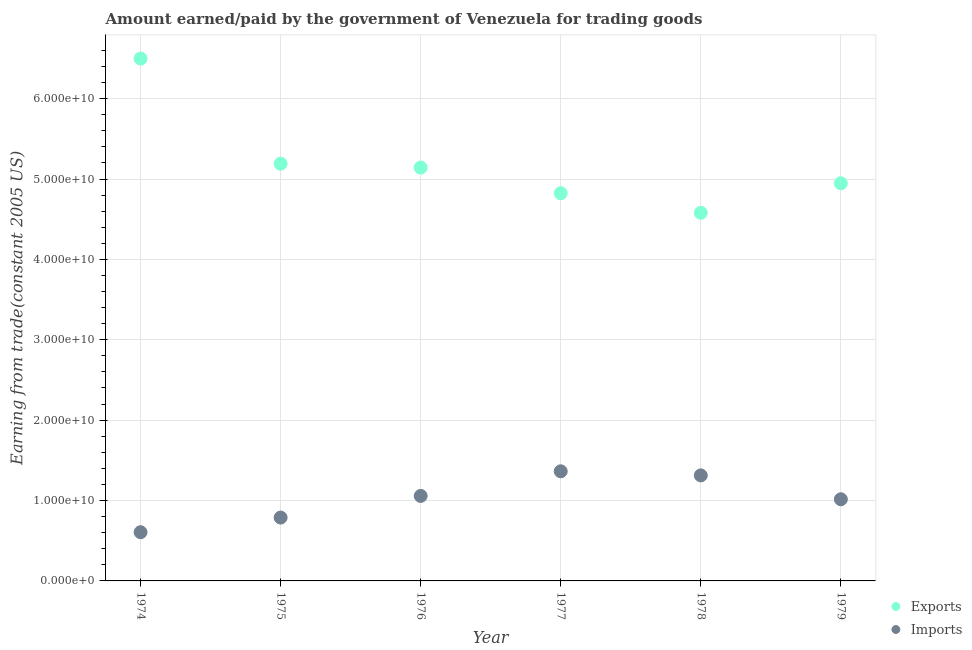What is the amount paid for imports in 1974?
Your answer should be compact. 6.06e+09. Across all years, what is the maximum amount paid for imports?
Give a very brief answer. 1.36e+1. Across all years, what is the minimum amount paid for imports?
Provide a short and direct response. 6.06e+09. In which year was the amount earned from exports maximum?
Your answer should be compact. 1974. In which year was the amount paid for imports minimum?
Your answer should be compact. 1974. What is the total amount paid for imports in the graph?
Ensure brevity in your answer.  6.14e+1. What is the difference between the amount earned from exports in 1975 and that in 1979?
Ensure brevity in your answer.  2.44e+09. What is the difference between the amount earned from exports in 1975 and the amount paid for imports in 1977?
Your answer should be compact. 3.83e+1. What is the average amount earned from exports per year?
Your answer should be very brief. 5.20e+1. In the year 1978, what is the difference between the amount paid for imports and amount earned from exports?
Ensure brevity in your answer.  -3.27e+1. What is the ratio of the amount paid for imports in 1975 to that in 1978?
Give a very brief answer. 0.6. Is the difference between the amount paid for imports in 1975 and 1978 greater than the difference between the amount earned from exports in 1975 and 1978?
Give a very brief answer. No. What is the difference between the highest and the second highest amount paid for imports?
Give a very brief answer. 5.11e+08. What is the difference between the highest and the lowest amount earned from exports?
Ensure brevity in your answer.  1.92e+1. In how many years, is the amount paid for imports greater than the average amount paid for imports taken over all years?
Give a very brief answer. 3. Is the sum of the amount paid for imports in 1978 and 1979 greater than the maximum amount earned from exports across all years?
Make the answer very short. No. Is the amount earned from exports strictly greater than the amount paid for imports over the years?
Offer a very short reply. Yes. Is the amount paid for imports strictly less than the amount earned from exports over the years?
Offer a terse response. Yes. How many dotlines are there?
Provide a short and direct response. 2. Does the graph contain any zero values?
Your answer should be very brief. No. Where does the legend appear in the graph?
Provide a succinct answer. Bottom right. How many legend labels are there?
Keep it short and to the point. 2. What is the title of the graph?
Your answer should be compact. Amount earned/paid by the government of Venezuela for trading goods. Does "Commercial bank branches" appear as one of the legend labels in the graph?
Provide a succinct answer. No. What is the label or title of the Y-axis?
Provide a succinct answer. Earning from trade(constant 2005 US). What is the Earning from trade(constant 2005 US) in Exports in 1974?
Provide a short and direct response. 6.50e+1. What is the Earning from trade(constant 2005 US) in Imports in 1974?
Offer a terse response. 6.06e+09. What is the Earning from trade(constant 2005 US) in Exports in 1975?
Your answer should be compact. 5.19e+1. What is the Earning from trade(constant 2005 US) of Imports in 1975?
Make the answer very short. 7.88e+09. What is the Earning from trade(constant 2005 US) of Exports in 1976?
Make the answer very short. 5.14e+1. What is the Earning from trade(constant 2005 US) in Imports in 1976?
Your response must be concise. 1.06e+1. What is the Earning from trade(constant 2005 US) of Exports in 1977?
Provide a succinct answer. 4.82e+1. What is the Earning from trade(constant 2005 US) of Imports in 1977?
Give a very brief answer. 1.36e+1. What is the Earning from trade(constant 2005 US) of Exports in 1978?
Your answer should be very brief. 4.58e+1. What is the Earning from trade(constant 2005 US) in Imports in 1978?
Make the answer very short. 1.31e+1. What is the Earning from trade(constant 2005 US) in Exports in 1979?
Your answer should be very brief. 4.95e+1. What is the Earning from trade(constant 2005 US) of Imports in 1979?
Your answer should be very brief. 1.02e+1. Across all years, what is the maximum Earning from trade(constant 2005 US) in Exports?
Your response must be concise. 6.50e+1. Across all years, what is the maximum Earning from trade(constant 2005 US) of Imports?
Provide a succinct answer. 1.36e+1. Across all years, what is the minimum Earning from trade(constant 2005 US) in Exports?
Give a very brief answer. 4.58e+1. Across all years, what is the minimum Earning from trade(constant 2005 US) in Imports?
Your response must be concise. 6.06e+09. What is the total Earning from trade(constant 2005 US) of Exports in the graph?
Give a very brief answer. 3.12e+11. What is the total Earning from trade(constant 2005 US) of Imports in the graph?
Offer a very short reply. 6.14e+1. What is the difference between the Earning from trade(constant 2005 US) of Exports in 1974 and that in 1975?
Give a very brief answer. 1.31e+1. What is the difference between the Earning from trade(constant 2005 US) in Imports in 1974 and that in 1975?
Offer a terse response. -1.82e+09. What is the difference between the Earning from trade(constant 2005 US) in Exports in 1974 and that in 1976?
Make the answer very short. 1.36e+1. What is the difference between the Earning from trade(constant 2005 US) of Imports in 1974 and that in 1976?
Your answer should be very brief. -4.51e+09. What is the difference between the Earning from trade(constant 2005 US) in Exports in 1974 and that in 1977?
Your answer should be compact. 1.68e+1. What is the difference between the Earning from trade(constant 2005 US) in Imports in 1974 and that in 1977?
Keep it short and to the point. -7.58e+09. What is the difference between the Earning from trade(constant 2005 US) in Exports in 1974 and that in 1978?
Keep it short and to the point. 1.92e+1. What is the difference between the Earning from trade(constant 2005 US) of Imports in 1974 and that in 1978?
Make the answer very short. -7.07e+09. What is the difference between the Earning from trade(constant 2005 US) of Exports in 1974 and that in 1979?
Provide a succinct answer. 1.55e+1. What is the difference between the Earning from trade(constant 2005 US) of Imports in 1974 and that in 1979?
Provide a succinct answer. -4.10e+09. What is the difference between the Earning from trade(constant 2005 US) of Exports in 1975 and that in 1976?
Give a very brief answer. 4.81e+08. What is the difference between the Earning from trade(constant 2005 US) in Imports in 1975 and that in 1976?
Provide a succinct answer. -2.69e+09. What is the difference between the Earning from trade(constant 2005 US) of Exports in 1975 and that in 1977?
Your answer should be compact. 3.67e+09. What is the difference between the Earning from trade(constant 2005 US) in Imports in 1975 and that in 1977?
Ensure brevity in your answer.  -5.76e+09. What is the difference between the Earning from trade(constant 2005 US) in Exports in 1975 and that in 1978?
Ensure brevity in your answer.  6.11e+09. What is the difference between the Earning from trade(constant 2005 US) in Imports in 1975 and that in 1978?
Give a very brief answer. -5.25e+09. What is the difference between the Earning from trade(constant 2005 US) in Exports in 1975 and that in 1979?
Offer a very short reply. 2.44e+09. What is the difference between the Earning from trade(constant 2005 US) in Imports in 1975 and that in 1979?
Provide a short and direct response. -2.28e+09. What is the difference between the Earning from trade(constant 2005 US) in Exports in 1976 and that in 1977?
Offer a terse response. 3.19e+09. What is the difference between the Earning from trade(constant 2005 US) of Imports in 1976 and that in 1977?
Provide a short and direct response. -3.06e+09. What is the difference between the Earning from trade(constant 2005 US) of Exports in 1976 and that in 1978?
Your answer should be very brief. 5.63e+09. What is the difference between the Earning from trade(constant 2005 US) of Imports in 1976 and that in 1978?
Ensure brevity in your answer.  -2.55e+09. What is the difference between the Earning from trade(constant 2005 US) in Exports in 1976 and that in 1979?
Keep it short and to the point. 1.96e+09. What is the difference between the Earning from trade(constant 2005 US) of Imports in 1976 and that in 1979?
Offer a terse response. 4.14e+08. What is the difference between the Earning from trade(constant 2005 US) of Exports in 1977 and that in 1978?
Provide a short and direct response. 2.44e+09. What is the difference between the Earning from trade(constant 2005 US) in Imports in 1977 and that in 1978?
Your answer should be compact. 5.11e+08. What is the difference between the Earning from trade(constant 2005 US) in Exports in 1977 and that in 1979?
Give a very brief answer. -1.24e+09. What is the difference between the Earning from trade(constant 2005 US) of Imports in 1977 and that in 1979?
Your response must be concise. 3.48e+09. What is the difference between the Earning from trade(constant 2005 US) in Exports in 1978 and that in 1979?
Make the answer very short. -3.67e+09. What is the difference between the Earning from trade(constant 2005 US) in Imports in 1978 and that in 1979?
Your answer should be compact. 2.97e+09. What is the difference between the Earning from trade(constant 2005 US) of Exports in 1974 and the Earning from trade(constant 2005 US) of Imports in 1975?
Keep it short and to the point. 5.71e+1. What is the difference between the Earning from trade(constant 2005 US) in Exports in 1974 and the Earning from trade(constant 2005 US) in Imports in 1976?
Your response must be concise. 5.44e+1. What is the difference between the Earning from trade(constant 2005 US) in Exports in 1974 and the Earning from trade(constant 2005 US) in Imports in 1977?
Offer a very short reply. 5.13e+1. What is the difference between the Earning from trade(constant 2005 US) of Exports in 1974 and the Earning from trade(constant 2005 US) of Imports in 1978?
Your response must be concise. 5.19e+1. What is the difference between the Earning from trade(constant 2005 US) in Exports in 1974 and the Earning from trade(constant 2005 US) in Imports in 1979?
Provide a succinct answer. 5.48e+1. What is the difference between the Earning from trade(constant 2005 US) in Exports in 1975 and the Earning from trade(constant 2005 US) in Imports in 1976?
Offer a terse response. 4.13e+1. What is the difference between the Earning from trade(constant 2005 US) in Exports in 1975 and the Earning from trade(constant 2005 US) in Imports in 1977?
Your answer should be very brief. 3.83e+1. What is the difference between the Earning from trade(constant 2005 US) of Exports in 1975 and the Earning from trade(constant 2005 US) of Imports in 1978?
Give a very brief answer. 3.88e+1. What is the difference between the Earning from trade(constant 2005 US) in Exports in 1975 and the Earning from trade(constant 2005 US) in Imports in 1979?
Offer a terse response. 4.17e+1. What is the difference between the Earning from trade(constant 2005 US) of Exports in 1976 and the Earning from trade(constant 2005 US) of Imports in 1977?
Ensure brevity in your answer.  3.78e+1. What is the difference between the Earning from trade(constant 2005 US) of Exports in 1976 and the Earning from trade(constant 2005 US) of Imports in 1978?
Your response must be concise. 3.83e+1. What is the difference between the Earning from trade(constant 2005 US) in Exports in 1976 and the Earning from trade(constant 2005 US) in Imports in 1979?
Your response must be concise. 4.13e+1. What is the difference between the Earning from trade(constant 2005 US) in Exports in 1977 and the Earning from trade(constant 2005 US) in Imports in 1978?
Give a very brief answer. 3.51e+1. What is the difference between the Earning from trade(constant 2005 US) of Exports in 1977 and the Earning from trade(constant 2005 US) of Imports in 1979?
Ensure brevity in your answer.  3.81e+1. What is the difference between the Earning from trade(constant 2005 US) of Exports in 1978 and the Earning from trade(constant 2005 US) of Imports in 1979?
Provide a succinct answer. 3.56e+1. What is the average Earning from trade(constant 2005 US) in Exports per year?
Your answer should be very brief. 5.20e+1. What is the average Earning from trade(constant 2005 US) in Imports per year?
Ensure brevity in your answer.  1.02e+1. In the year 1974, what is the difference between the Earning from trade(constant 2005 US) of Exports and Earning from trade(constant 2005 US) of Imports?
Offer a very short reply. 5.89e+1. In the year 1975, what is the difference between the Earning from trade(constant 2005 US) in Exports and Earning from trade(constant 2005 US) in Imports?
Keep it short and to the point. 4.40e+1. In the year 1976, what is the difference between the Earning from trade(constant 2005 US) in Exports and Earning from trade(constant 2005 US) in Imports?
Make the answer very short. 4.09e+1. In the year 1977, what is the difference between the Earning from trade(constant 2005 US) of Exports and Earning from trade(constant 2005 US) of Imports?
Provide a short and direct response. 3.46e+1. In the year 1978, what is the difference between the Earning from trade(constant 2005 US) in Exports and Earning from trade(constant 2005 US) in Imports?
Offer a very short reply. 3.27e+1. In the year 1979, what is the difference between the Earning from trade(constant 2005 US) of Exports and Earning from trade(constant 2005 US) of Imports?
Your answer should be very brief. 3.93e+1. What is the ratio of the Earning from trade(constant 2005 US) in Exports in 1974 to that in 1975?
Ensure brevity in your answer.  1.25. What is the ratio of the Earning from trade(constant 2005 US) of Imports in 1974 to that in 1975?
Offer a terse response. 0.77. What is the ratio of the Earning from trade(constant 2005 US) in Exports in 1974 to that in 1976?
Your answer should be very brief. 1.26. What is the ratio of the Earning from trade(constant 2005 US) of Imports in 1974 to that in 1976?
Provide a succinct answer. 0.57. What is the ratio of the Earning from trade(constant 2005 US) in Exports in 1974 to that in 1977?
Your answer should be very brief. 1.35. What is the ratio of the Earning from trade(constant 2005 US) of Imports in 1974 to that in 1977?
Provide a succinct answer. 0.44. What is the ratio of the Earning from trade(constant 2005 US) in Exports in 1974 to that in 1978?
Your answer should be compact. 1.42. What is the ratio of the Earning from trade(constant 2005 US) of Imports in 1974 to that in 1978?
Offer a very short reply. 0.46. What is the ratio of the Earning from trade(constant 2005 US) in Exports in 1974 to that in 1979?
Your response must be concise. 1.31. What is the ratio of the Earning from trade(constant 2005 US) of Imports in 1974 to that in 1979?
Provide a succinct answer. 0.6. What is the ratio of the Earning from trade(constant 2005 US) in Exports in 1975 to that in 1976?
Offer a terse response. 1.01. What is the ratio of the Earning from trade(constant 2005 US) of Imports in 1975 to that in 1976?
Offer a terse response. 0.75. What is the ratio of the Earning from trade(constant 2005 US) of Exports in 1975 to that in 1977?
Your answer should be compact. 1.08. What is the ratio of the Earning from trade(constant 2005 US) of Imports in 1975 to that in 1977?
Provide a short and direct response. 0.58. What is the ratio of the Earning from trade(constant 2005 US) of Exports in 1975 to that in 1978?
Give a very brief answer. 1.13. What is the ratio of the Earning from trade(constant 2005 US) in Imports in 1975 to that in 1978?
Make the answer very short. 0.6. What is the ratio of the Earning from trade(constant 2005 US) of Exports in 1975 to that in 1979?
Your response must be concise. 1.05. What is the ratio of the Earning from trade(constant 2005 US) of Imports in 1975 to that in 1979?
Keep it short and to the point. 0.78. What is the ratio of the Earning from trade(constant 2005 US) in Exports in 1976 to that in 1977?
Your answer should be very brief. 1.07. What is the ratio of the Earning from trade(constant 2005 US) of Imports in 1976 to that in 1977?
Your answer should be compact. 0.78. What is the ratio of the Earning from trade(constant 2005 US) in Exports in 1976 to that in 1978?
Provide a succinct answer. 1.12. What is the ratio of the Earning from trade(constant 2005 US) of Imports in 1976 to that in 1978?
Your response must be concise. 0.81. What is the ratio of the Earning from trade(constant 2005 US) in Exports in 1976 to that in 1979?
Offer a terse response. 1.04. What is the ratio of the Earning from trade(constant 2005 US) of Imports in 1976 to that in 1979?
Give a very brief answer. 1.04. What is the ratio of the Earning from trade(constant 2005 US) in Exports in 1977 to that in 1978?
Your answer should be compact. 1.05. What is the ratio of the Earning from trade(constant 2005 US) in Imports in 1977 to that in 1978?
Make the answer very short. 1.04. What is the ratio of the Earning from trade(constant 2005 US) of Exports in 1977 to that in 1979?
Provide a short and direct response. 0.97. What is the ratio of the Earning from trade(constant 2005 US) in Imports in 1977 to that in 1979?
Ensure brevity in your answer.  1.34. What is the ratio of the Earning from trade(constant 2005 US) of Exports in 1978 to that in 1979?
Provide a succinct answer. 0.93. What is the ratio of the Earning from trade(constant 2005 US) in Imports in 1978 to that in 1979?
Keep it short and to the point. 1.29. What is the difference between the highest and the second highest Earning from trade(constant 2005 US) of Exports?
Give a very brief answer. 1.31e+1. What is the difference between the highest and the second highest Earning from trade(constant 2005 US) of Imports?
Offer a very short reply. 5.11e+08. What is the difference between the highest and the lowest Earning from trade(constant 2005 US) of Exports?
Ensure brevity in your answer.  1.92e+1. What is the difference between the highest and the lowest Earning from trade(constant 2005 US) of Imports?
Keep it short and to the point. 7.58e+09. 